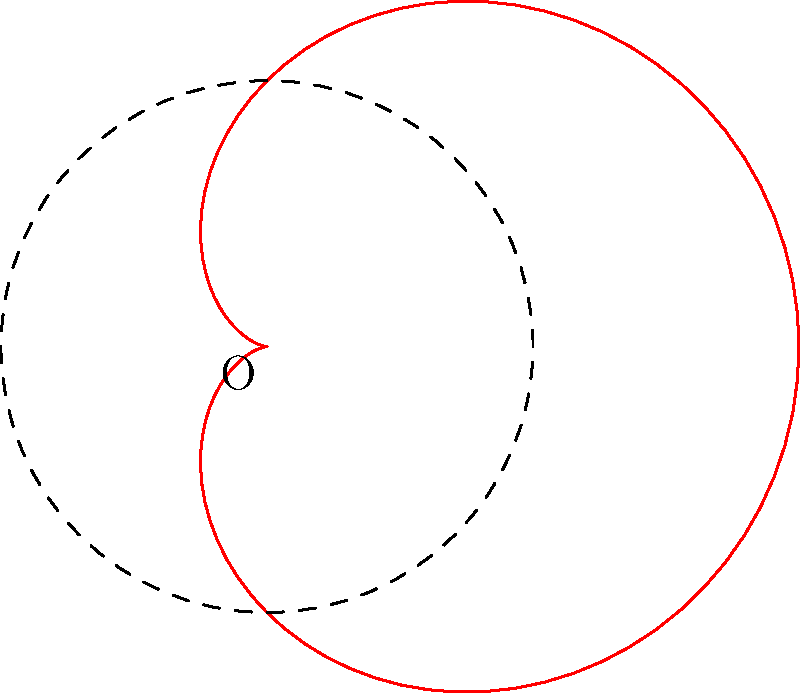In the authentication process of a circular art piece, you encounter a cardioid-shaped area defined by the polar equation $r = 2(1 + \cos\theta)$. If the diameter of the circular art piece is 4 units, what fraction of the art piece's area is enclosed by the cardioid? To solve this problem, let's follow these steps:

1) The area of a polar curve is given by the formula:
   $$A = \frac{1}{2} \int_0^{2\pi} r^2 d\theta$$

2) For our cardioid, $r = 2(1 + \cos\theta)$. Let's square this:
   $$r^2 = 4(1 + 2\cos\theta + \cos^2\theta)$$

3) Now, let's integrate:
   $$A = \frac{1}{2} \int_0^{2\pi} 4(1 + 2\cos\theta + \cos^2\theta) d\theta$$
   $$= 2 \int_0^{2\pi} (1 + 2\cos\theta + \cos^2\theta) d\theta$$

4) Integrate each term:
   - $\int_0^{2\pi} 1 d\theta = 2\pi$
   - $\int_0^{2\pi} 2\cos\theta d\theta = 0$
   - $\int_0^{2\pi} \cos^2\theta d\theta = \pi$

5) Therefore, the area of the cardioid is:
   $$A = 2(2\pi + \pi) = 6\pi$$

6) The circular art piece has a diameter of 4, so its radius is 2. Its area is:
   $$A_{circle} = \pi r^2 = \pi(2)^2 = 4\pi$$

7) The fraction of the art piece's area enclosed by the cardioid is:
   $$\frac{A_{cardioid}}{A_{circle}} = \frac{6\pi}{4\pi} = \frac{3}{2}$$
Answer: $\frac{3}{2}$ 